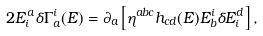Convert formula to latex. <formula><loc_0><loc_0><loc_500><loc_500>2 E ^ { a } _ { i } \delta \Gamma _ { a } ^ { i } ( E ) = \partial _ { a } \left [ \eta ^ { a b c } h _ { c d } ( E ) E _ { b } ^ { i } \delta E ^ { d } _ { i } \right ] ,</formula> 